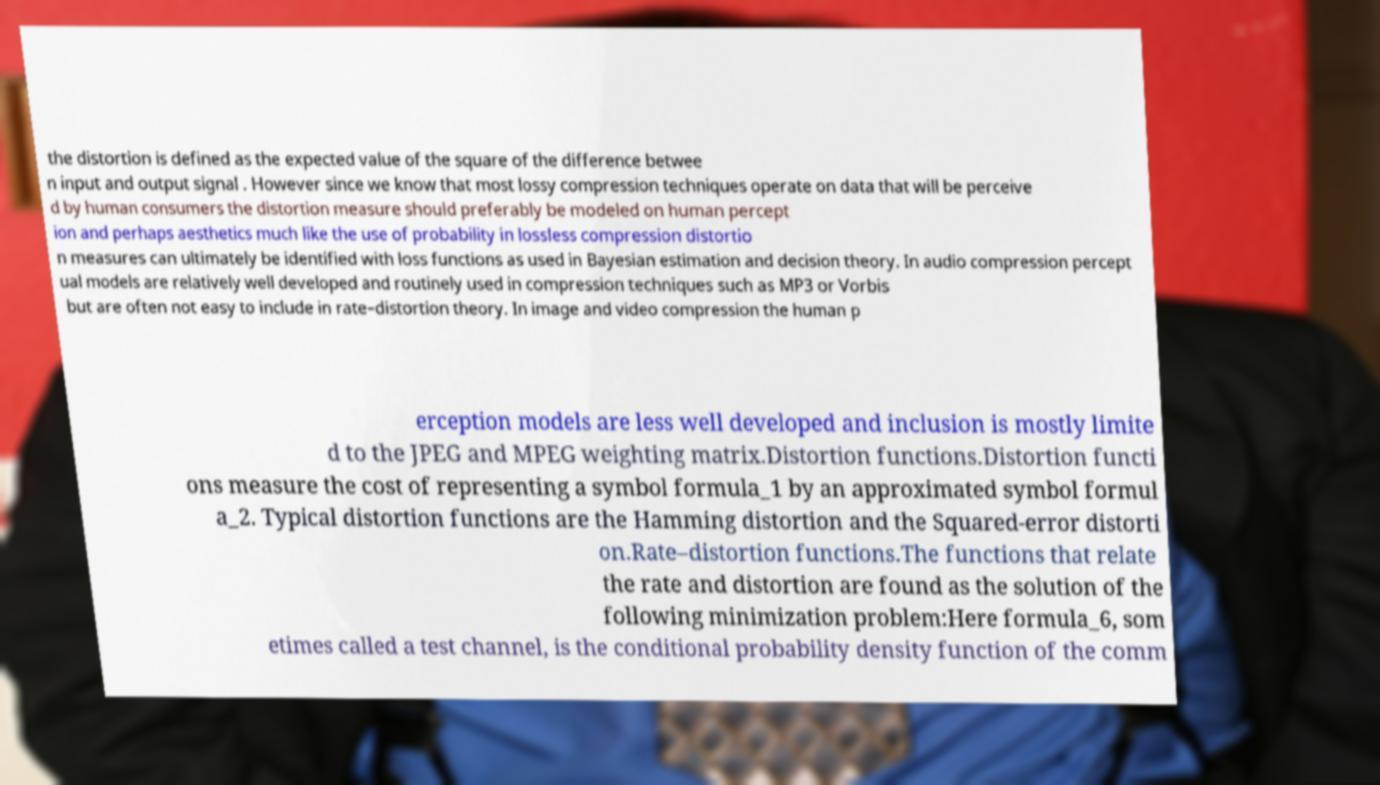Please identify and transcribe the text found in this image. the distortion is defined as the expected value of the square of the difference betwee n input and output signal . However since we know that most lossy compression techniques operate on data that will be perceive d by human consumers the distortion measure should preferably be modeled on human percept ion and perhaps aesthetics much like the use of probability in lossless compression distortio n measures can ultimately be identified with loss functions as used in Bayesian estimation and decision theory. In audio compression percept ual models are relatively well developed and routinely used in compression techniques such as MP3 or Vorbis but are often not easy to include in rate–distortion theory. In image and video compression the human p erception models are less well developed and inclusion is mostly limite d to the JPEG and MPEG weighting matrix.Distortion functions.Distortion functi ons measure the cost of representing a symbol formula_1 by an approximated symbol formul a_2. Typical distortion functions are the Hamming distortion and the Squared-error distorti on.Rate–distortion functions.The functions that relate the rate and distortion are found as the solution of the following minimization problem:Here formula_6, som etimes called a test channel, is the conditional probability density function of the comm 